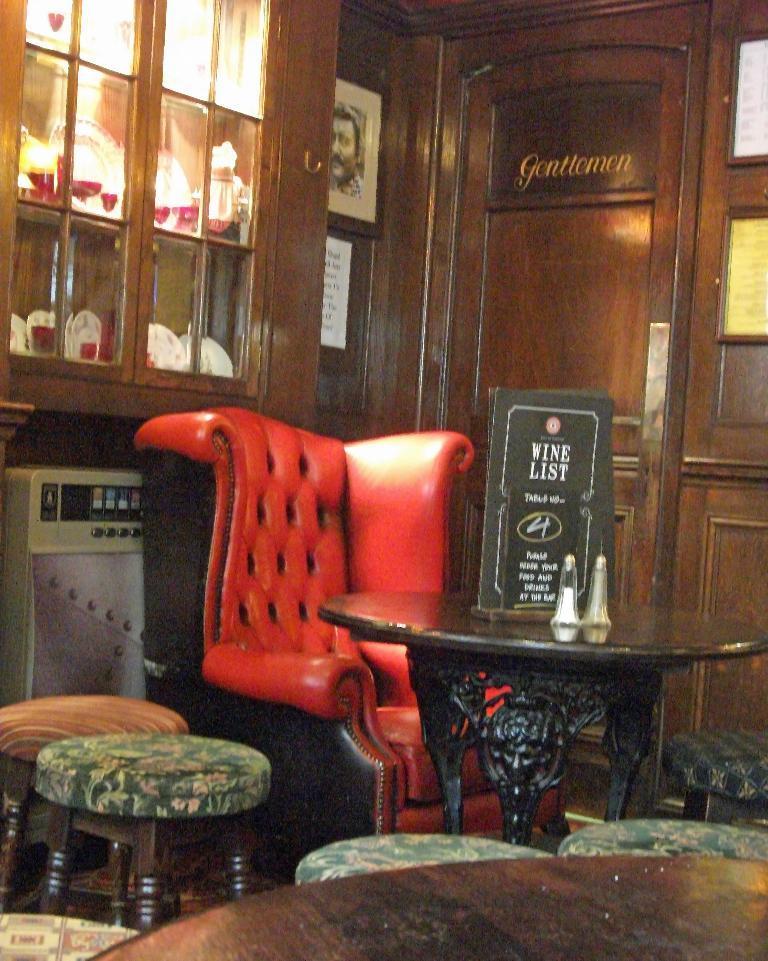Please provide a concise description of this image. In this picture we can see frames on the wall. We can see stools, chair and objects on the table. On the left side of the picture we can see objects in the cupboard. 